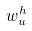<formula> <loc_0><loc_0><loc_500><loc_500>w _ { u } ^ { h }</formula> 